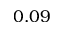Convert formula to latex. <formula><loc_0><loc_0><loc_500><loc_500>0 . 0 9</formula> 